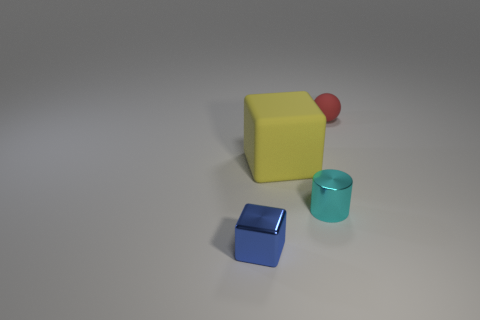There is a small red rubber ball; how many tiny red balls are on the right side of it?
Give a very brief answer. 0. There is a tiny thing that is the same material as the small cyan cylinder; what shape is it?
Your answer should be compact. Cube. Are there fewer tiny metal objects behind the small blue thing than balls in front of the large yellow rubber thing?
Your response must be concise. No. Are there more blue matte cylinders than shiny objects?
Your answer should be compact. No. What is the material of the tiny red object?
Provide a succinct answer. Rubber. The matte object on the right side of the matte cube is what color?
Offer a terse response. Red. Are there more tiny cyan cylinders that are on the left side of the big yellow rubber object than small blue metal blocks behind the tiny shiny cube?
Your response must be concise. No. There is a object on the left side of the rubber thing that is in front of the rubber thing on the right side of the cyan shiny thing; what size is it?
Offer a terse response. Small. Is there a big thing that has the same color as the small sphere?
Your answer should be very brief. No. What number of small objects are there?
Keep it short and to the point. 3. 